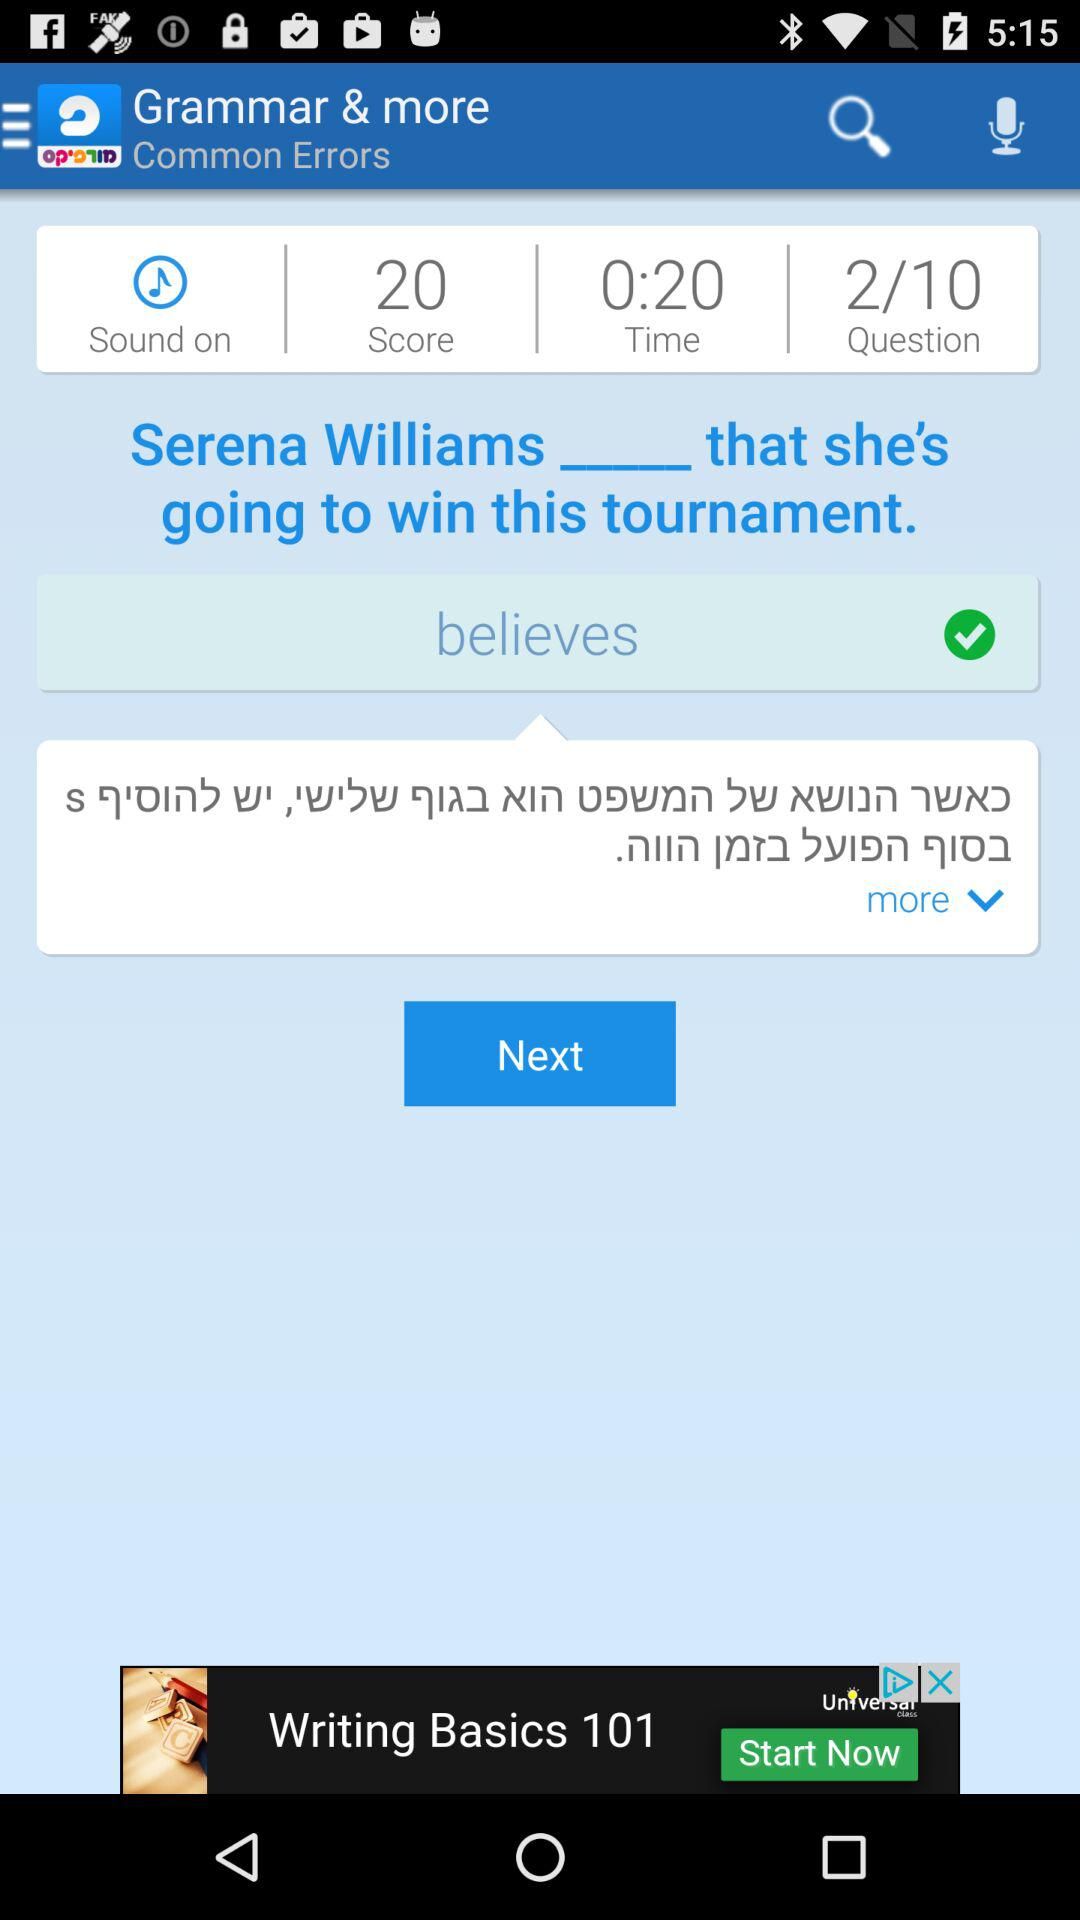What is the score? The score is 20. 